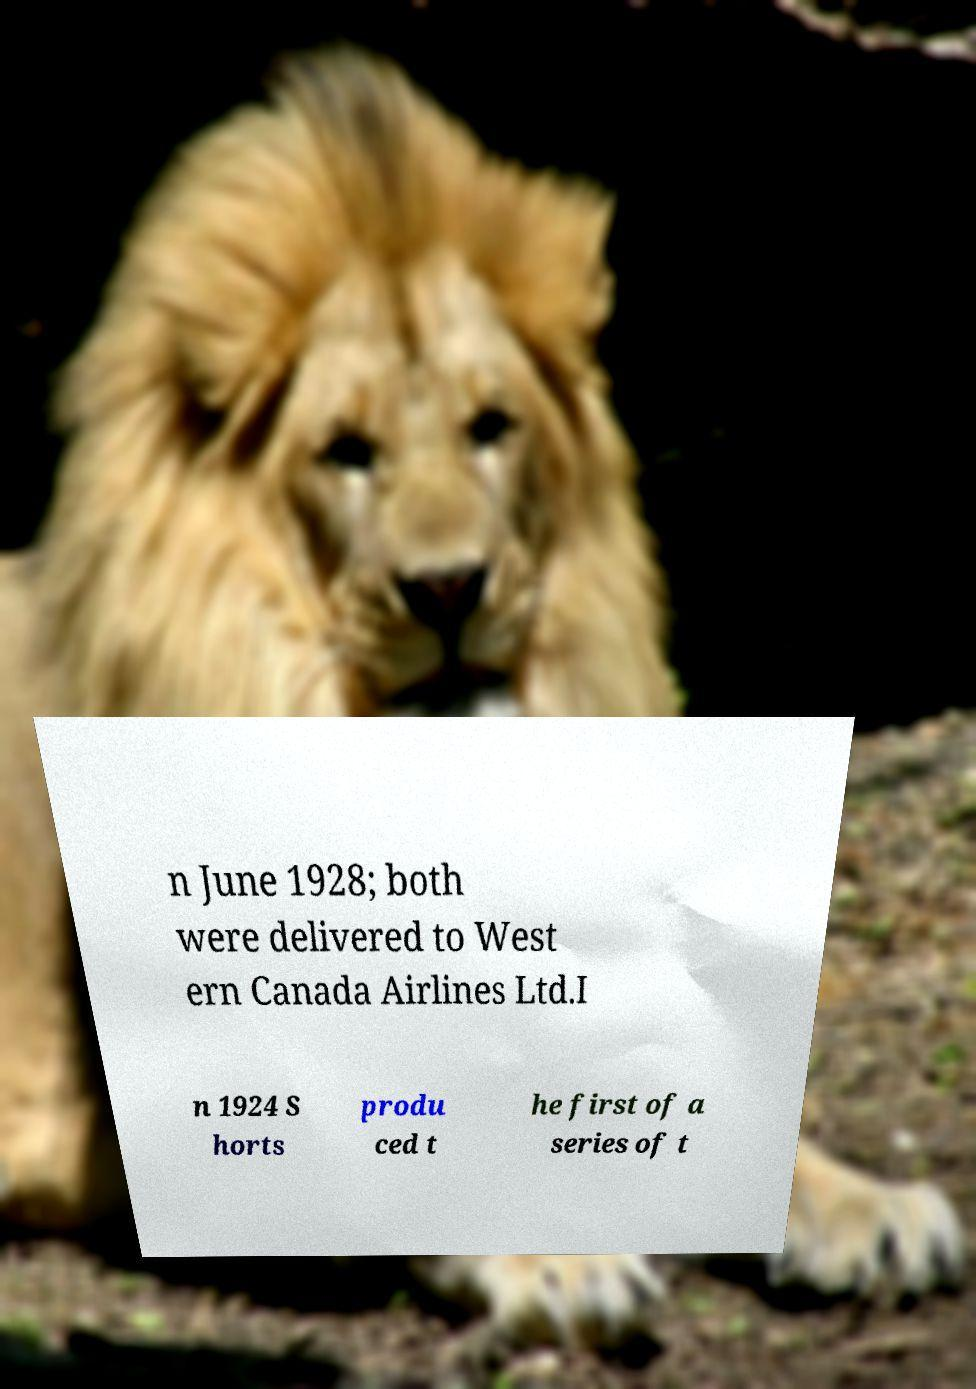Could you extract and type out the text from this image? n June 1928; both were delivered to West ern Canada Airlines Ltd.I n 1924 S horts produ ced t he first of a series of t 